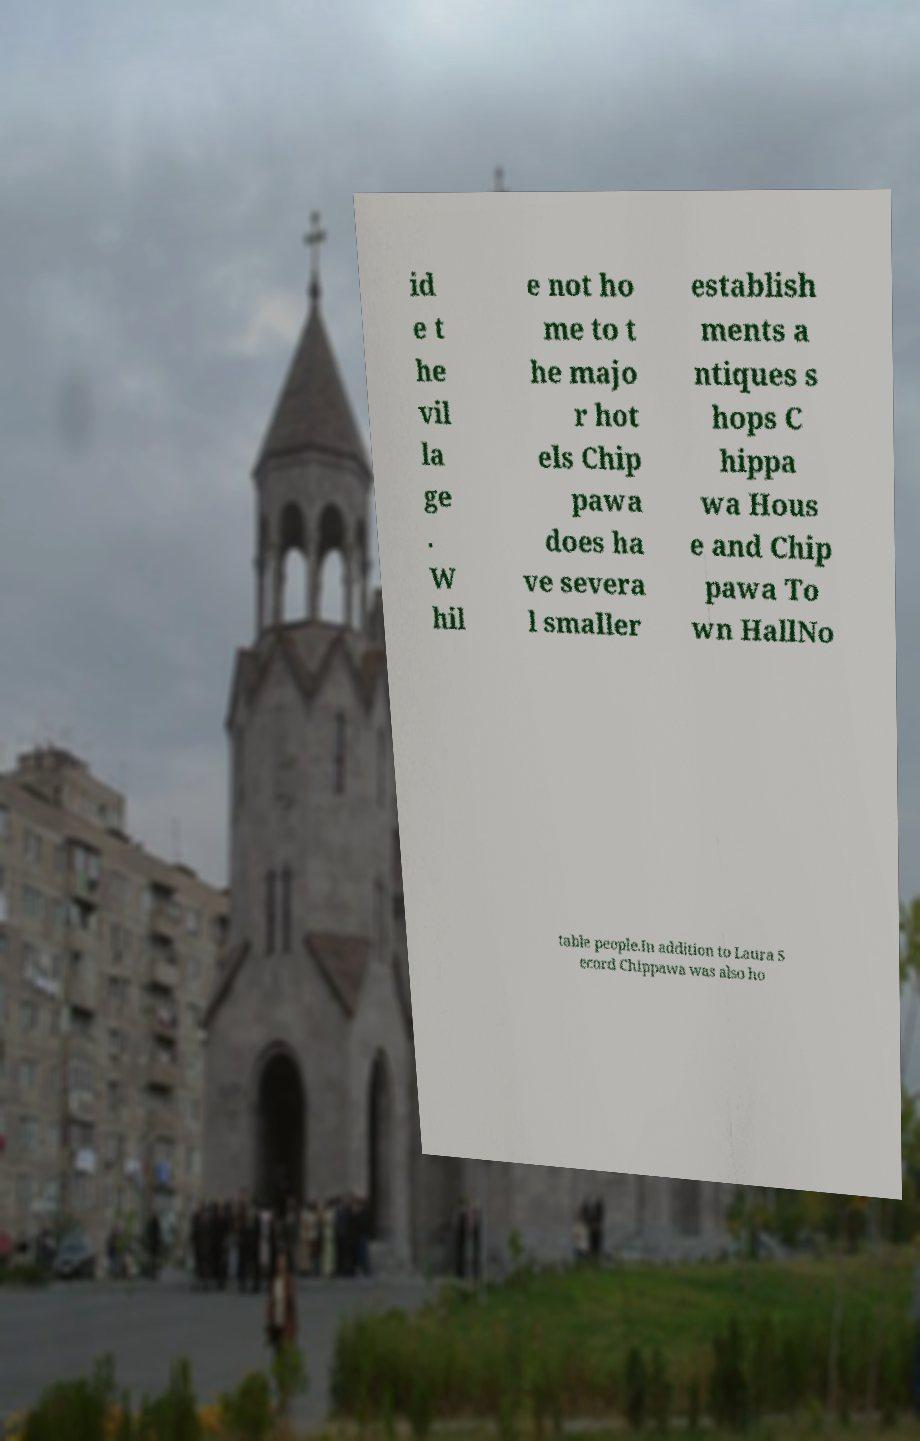Could you assist in decoding the text presented in this image and type it out clearly? id e t he vil la ge . W hil e not ho me to t he majo r hot els Chip pawa does ha ve severa l smaller establish ments a ntiques s hops C hippa wa Hous e and Chip pawa To wn HallNo table people.In addition to Laura S ecord Chippawa was also ho 